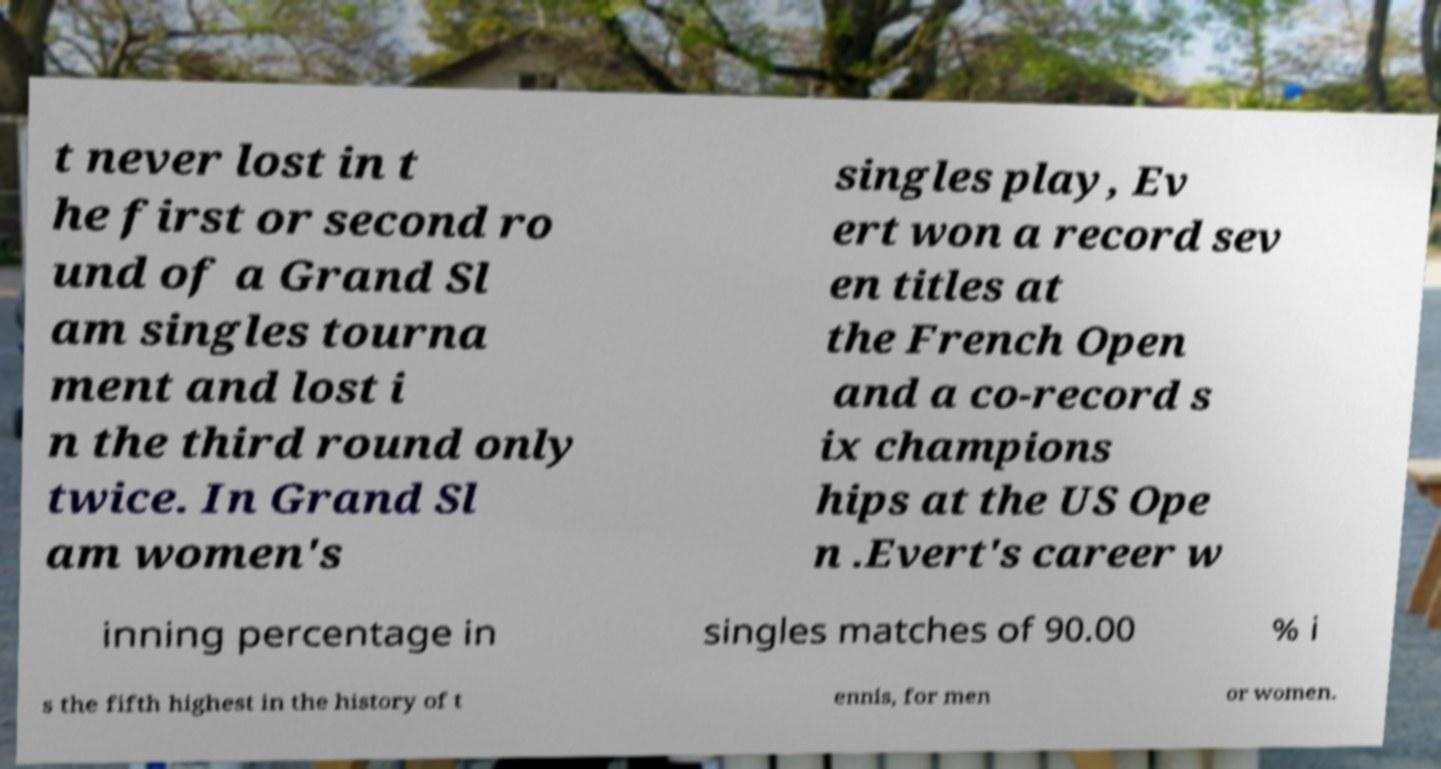Please read and relay the text visible in this image. What does it say? t never lost in t he first or second ro und of a Grand Sl am singles tourna ment and lost i n the third round only twice. In Grand Sl am women's singles play, Ev ert won a record sev en titles at the French Open and a co-record s ix champions hips at the US Ope n .Evert's career w inning percentage in singles matches of 90.00 % i s the fifth highest in the history of t ennis, for men or women. 